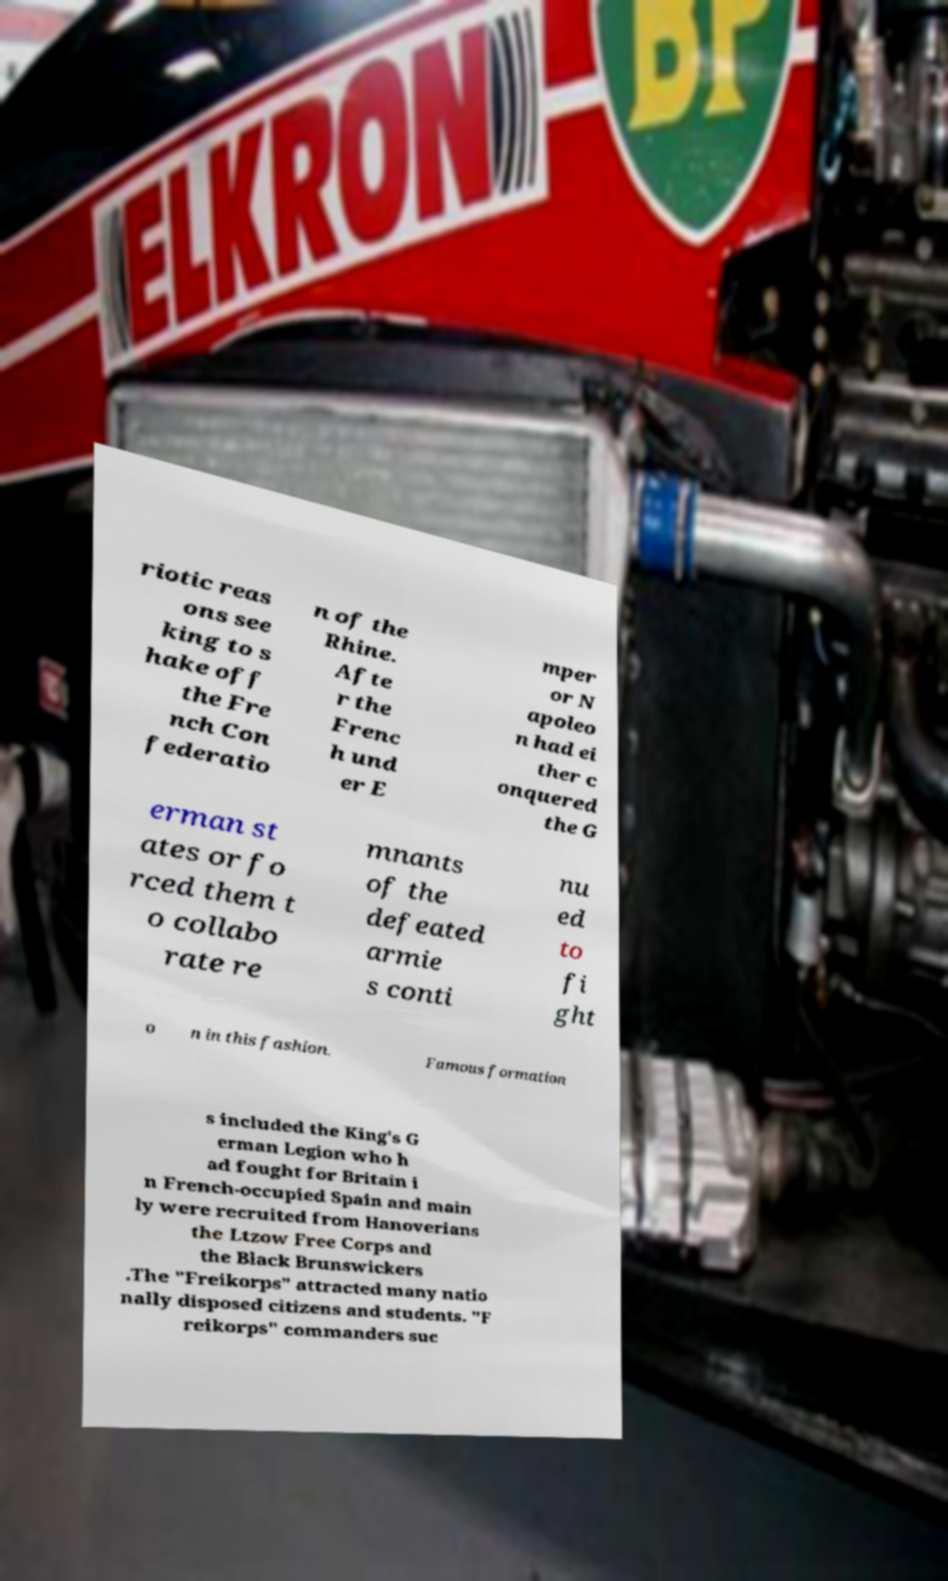Could you extract and type out the text from this image? riotic reas ons see king to s hake off the Fre nch Con federatio n of the Rhine. Afte r the Frenc h und er E mper or N apoleo n had ei ther c onquered the G erman st ates or fo rced them t o collabo rate re mnants of the defeated armie s conti nu ed to fi ght o n in this fashion. Famous formation s included the King's G erman Legion who h ad fought for Britain i n French-occupied Spain and main ly were recruited from Hanoverians the Ltzow Free Corps and the Black Brunswickers .The "Freikorps" attracted many natio nally disposed citizens and students. "F reikorps" commanders suc 